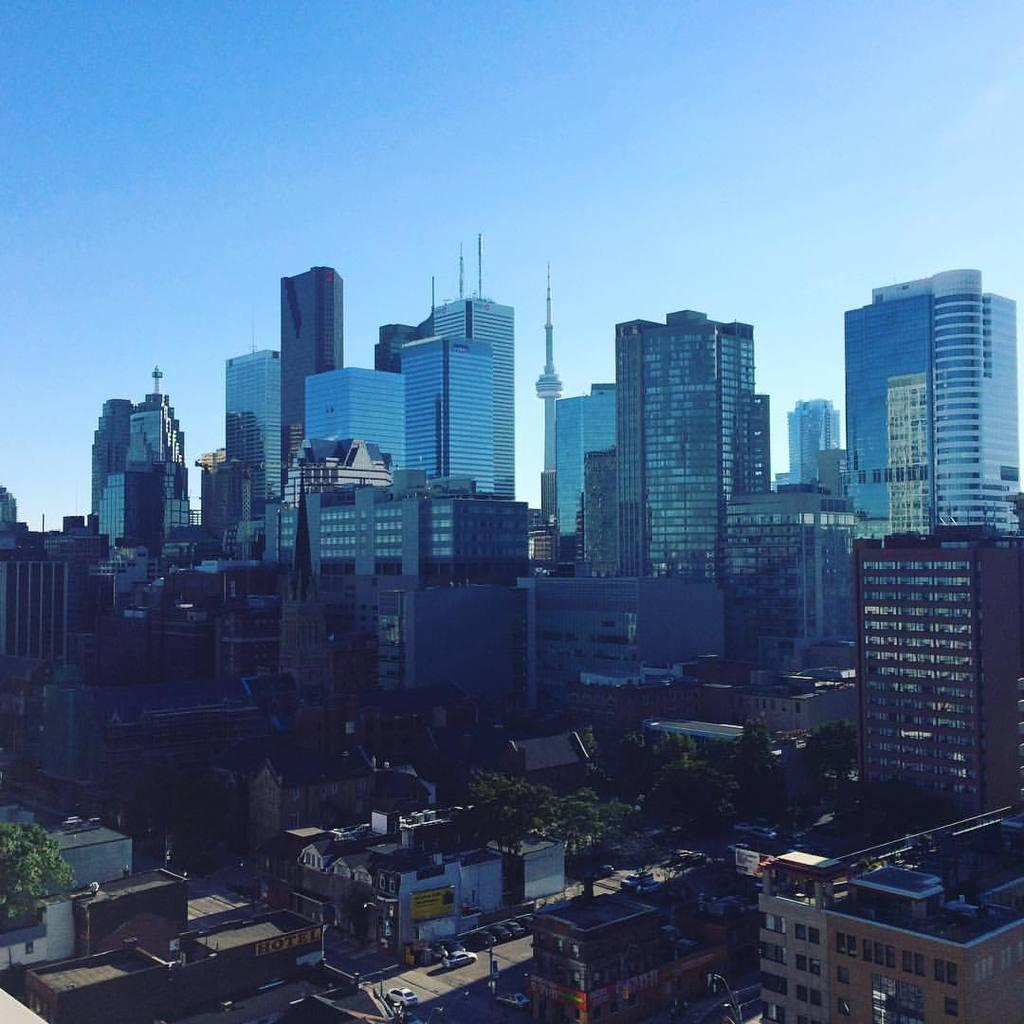What type of structures can be seen in the image? There are many buildings in the image. What other natural elements are present in the image? There are trees in the image. What mode of transportation can be seen on the road in the image? There are vehicles on the road in the image. What is visible in the background of the image? The sky is visible in the background of the image. What level of pollution can be seen in the image? There is no indication of pollution in the image; it only shows buildings, trees, vehicles, and the sky. Is there a church visible in the image? There is no church present in the image. 